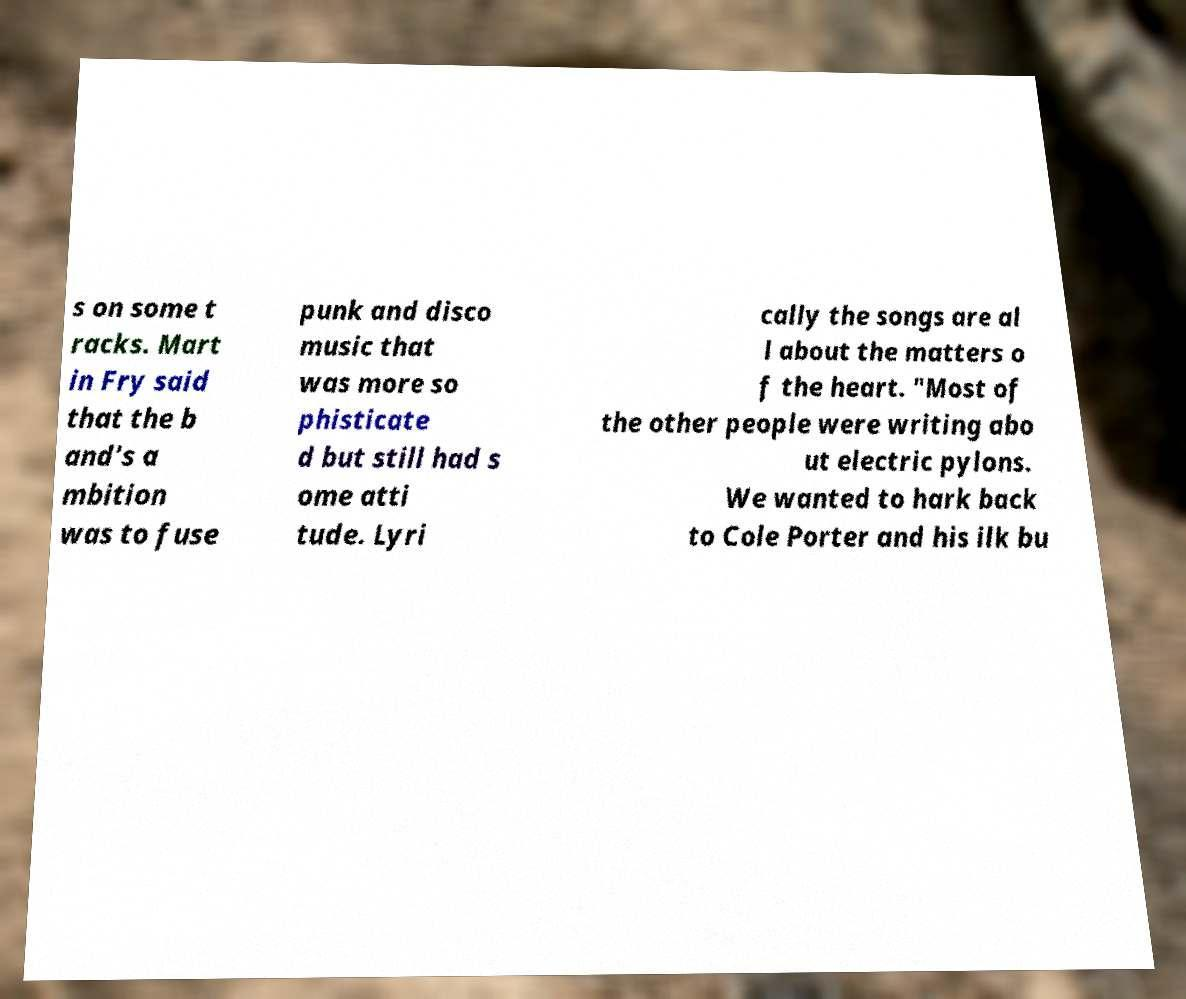Can you accurately transcribe the text from the provided image for me? s on some t racks. Mart in Fry said that the b and's a mbition was to fuse punk and disco music that was more so phisticate d but still had s ome atti tude. Lyri cally the songs are al l about the matters o f the heart. "Most of the other people were writing abo ut electric pylons. We wanted to hark back to Cole Porter and his ilk bu 